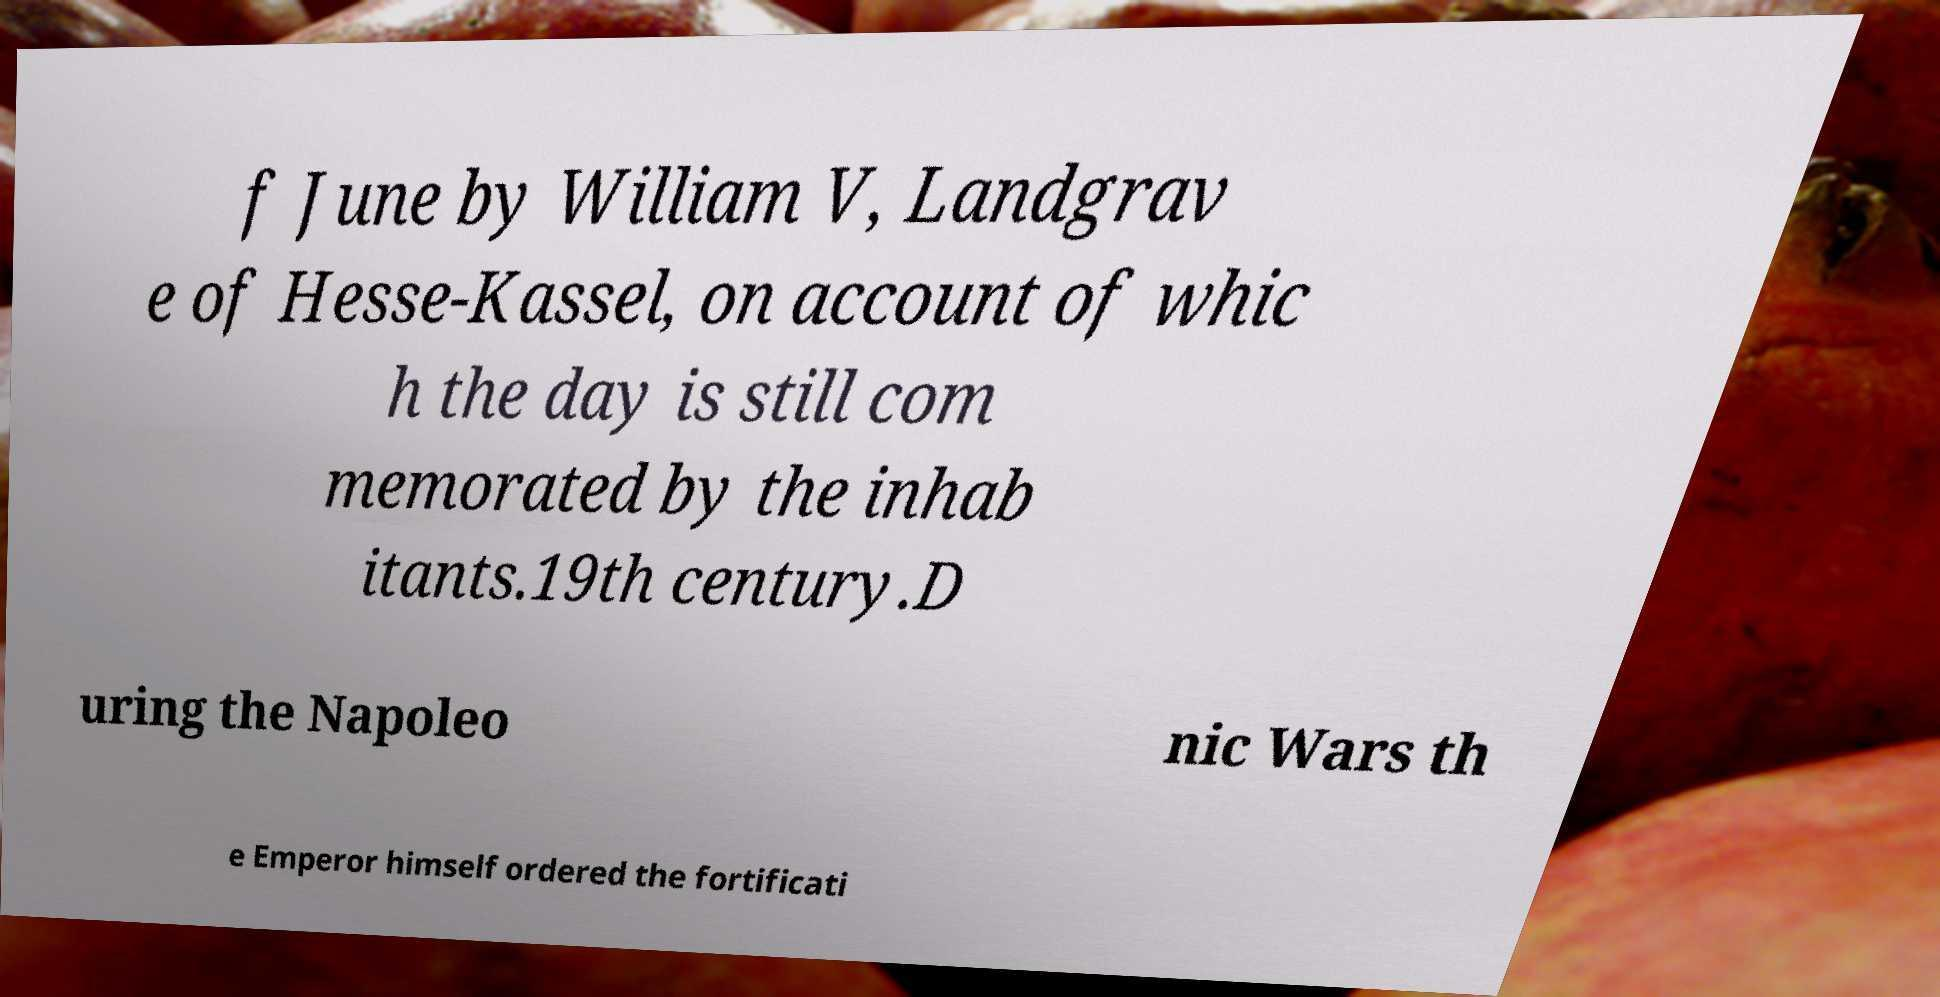There's text embedded in this image that I need extracted. Can you transcribe it verbatim? f June by William V, Landgrav e of Hesse-Kassel, on account of whic h the day is still com memorated by the inhab itants.19th century.D uring the Napoleo nic Wars th e Emperor himself ordered the fortificati 